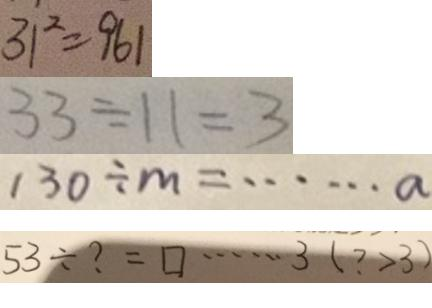<formula> <loc_0><loc_0><loc_500><loc_500>3 1 ^ { 2 } = 9 6 1 
 3 3 \div 1 1 = 3 
 1 3 0 \div m = \cdots a 
 5 3 \div ? = \square \cdots 3 ( ? > 3 )</formula> 